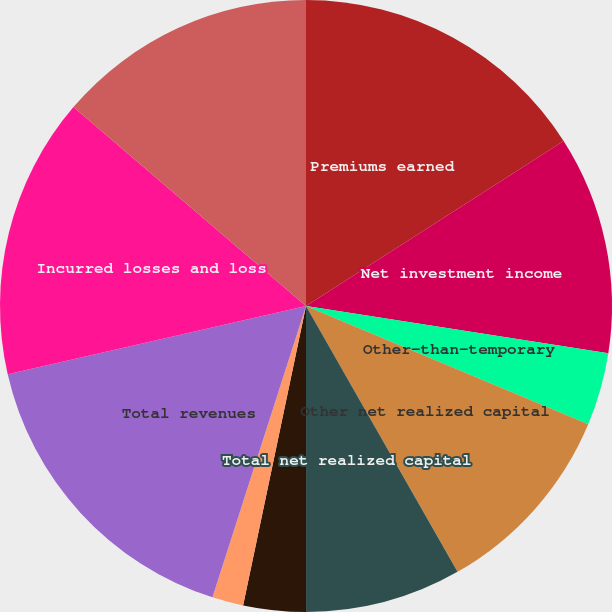Convert chart to OTSL. <chart><loc_0><loc_0><loc_500><loc_500><pie_chart><fcel>Premiums earned<fcel>Net investment income<fcel>Other-than-temporary<fcel>Other net realized capital<fcel>Total net realized capital<fcel>Net derivative gain (loss)<fcel>Other income (expense)<fcel>Total revenues<fcel>Incurred losses and loss<fcel>Commission brokerage taxes and<nl><fcel>15.93%<fcel>11.54%<fcel>3.85%<fcel>10.44%<fcel>8.24%<fcel>3.3%<fcel>1.65%<fcel>16.48%<fcel>14.84%<fcel>13.74%<nl></chart> 